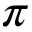Convert formula to latex. <formula><loc_0><loc_0><loc_500><loc_500>\pi</formula> 